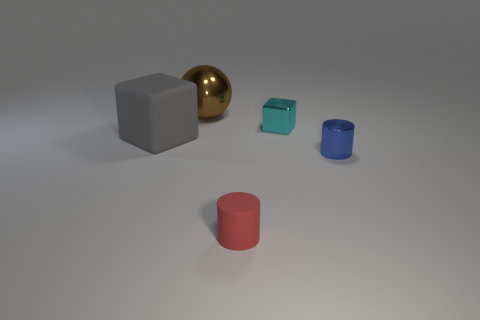Is there any other thing that is the same shape as the large brown object?
Provide a succinct answer. No. What is the block that is left of the small metallic thing that is behind the tiny blue metal object that is in front of the tiny cyan metal object made of?
Keep it short and to the point. Rubber. There is a object behind the metallic block; is it the same size as the large cube?
Keep it short and to the point. Yes. There is a object behind the cyan block; what material is it?
Your answer should be very brief. Metal. Are there more tiny blue things than large cyan matte objects?
Keep it short and to the point. Yes. What number of objects are either big things to the left of the shiny ball or tiny purple shiny spheres?
Offer a terse response. 1. There is a shiny object in front of the cyan shiny block; how many small cylinders are on the right side of it?
Provide a succinct answer. 0. There is a matte object that is behind the shiny object that is in front of the matte object left of the red thing; what size is it?
Make the answer very short. Large. What size is the red matte object that is the same shape as the blue thing?
Ensure brevity in your answer.  Small. How many objects are either things to the right of the brown object or objects that are in front of the large rubber object?
Keep it short and to the point. 3. 